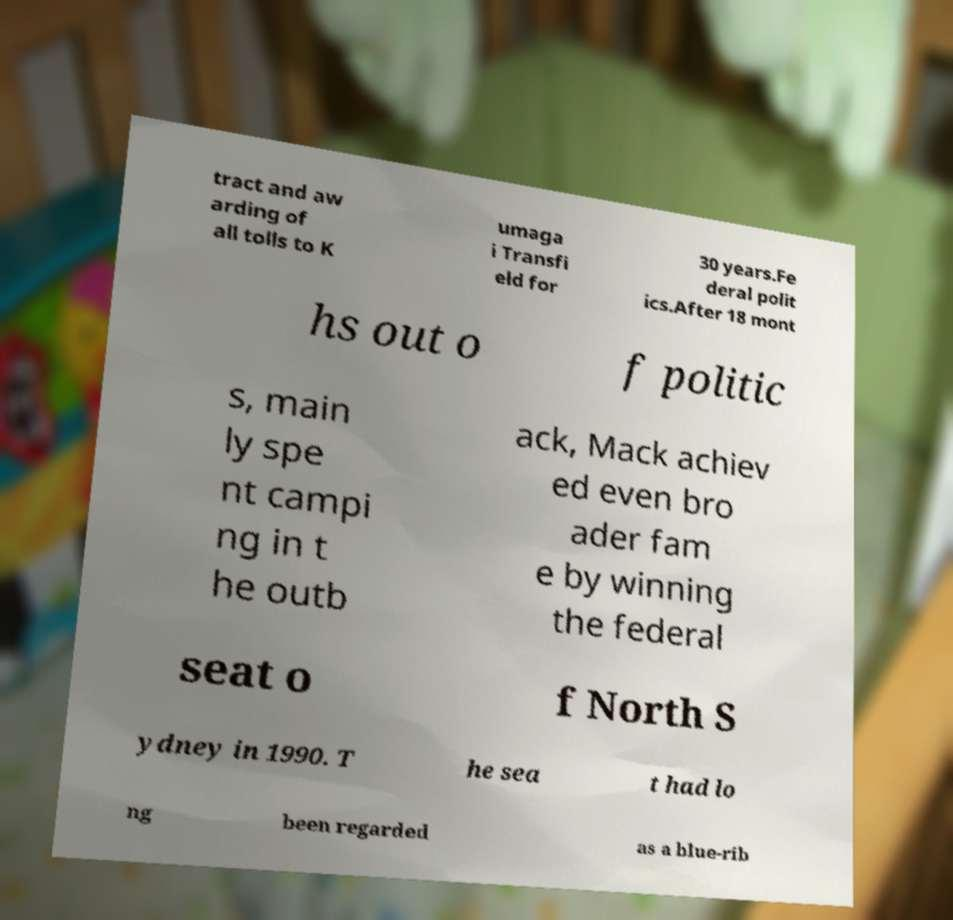I need the written content from this picture converted into text. Can you do that? tract and aw arding of all tolls to K umaga i Transfi eld for 30 years.Fe deral polit ics.After 18 mont hs out o f politic s, main ly spe nt campi ng in t he outb ack, Mack achiev ed even bro ader fam e by winning the federal seat o f North S ydney in 1990. T he sea t had lo ng been regarded as a blue-rib 